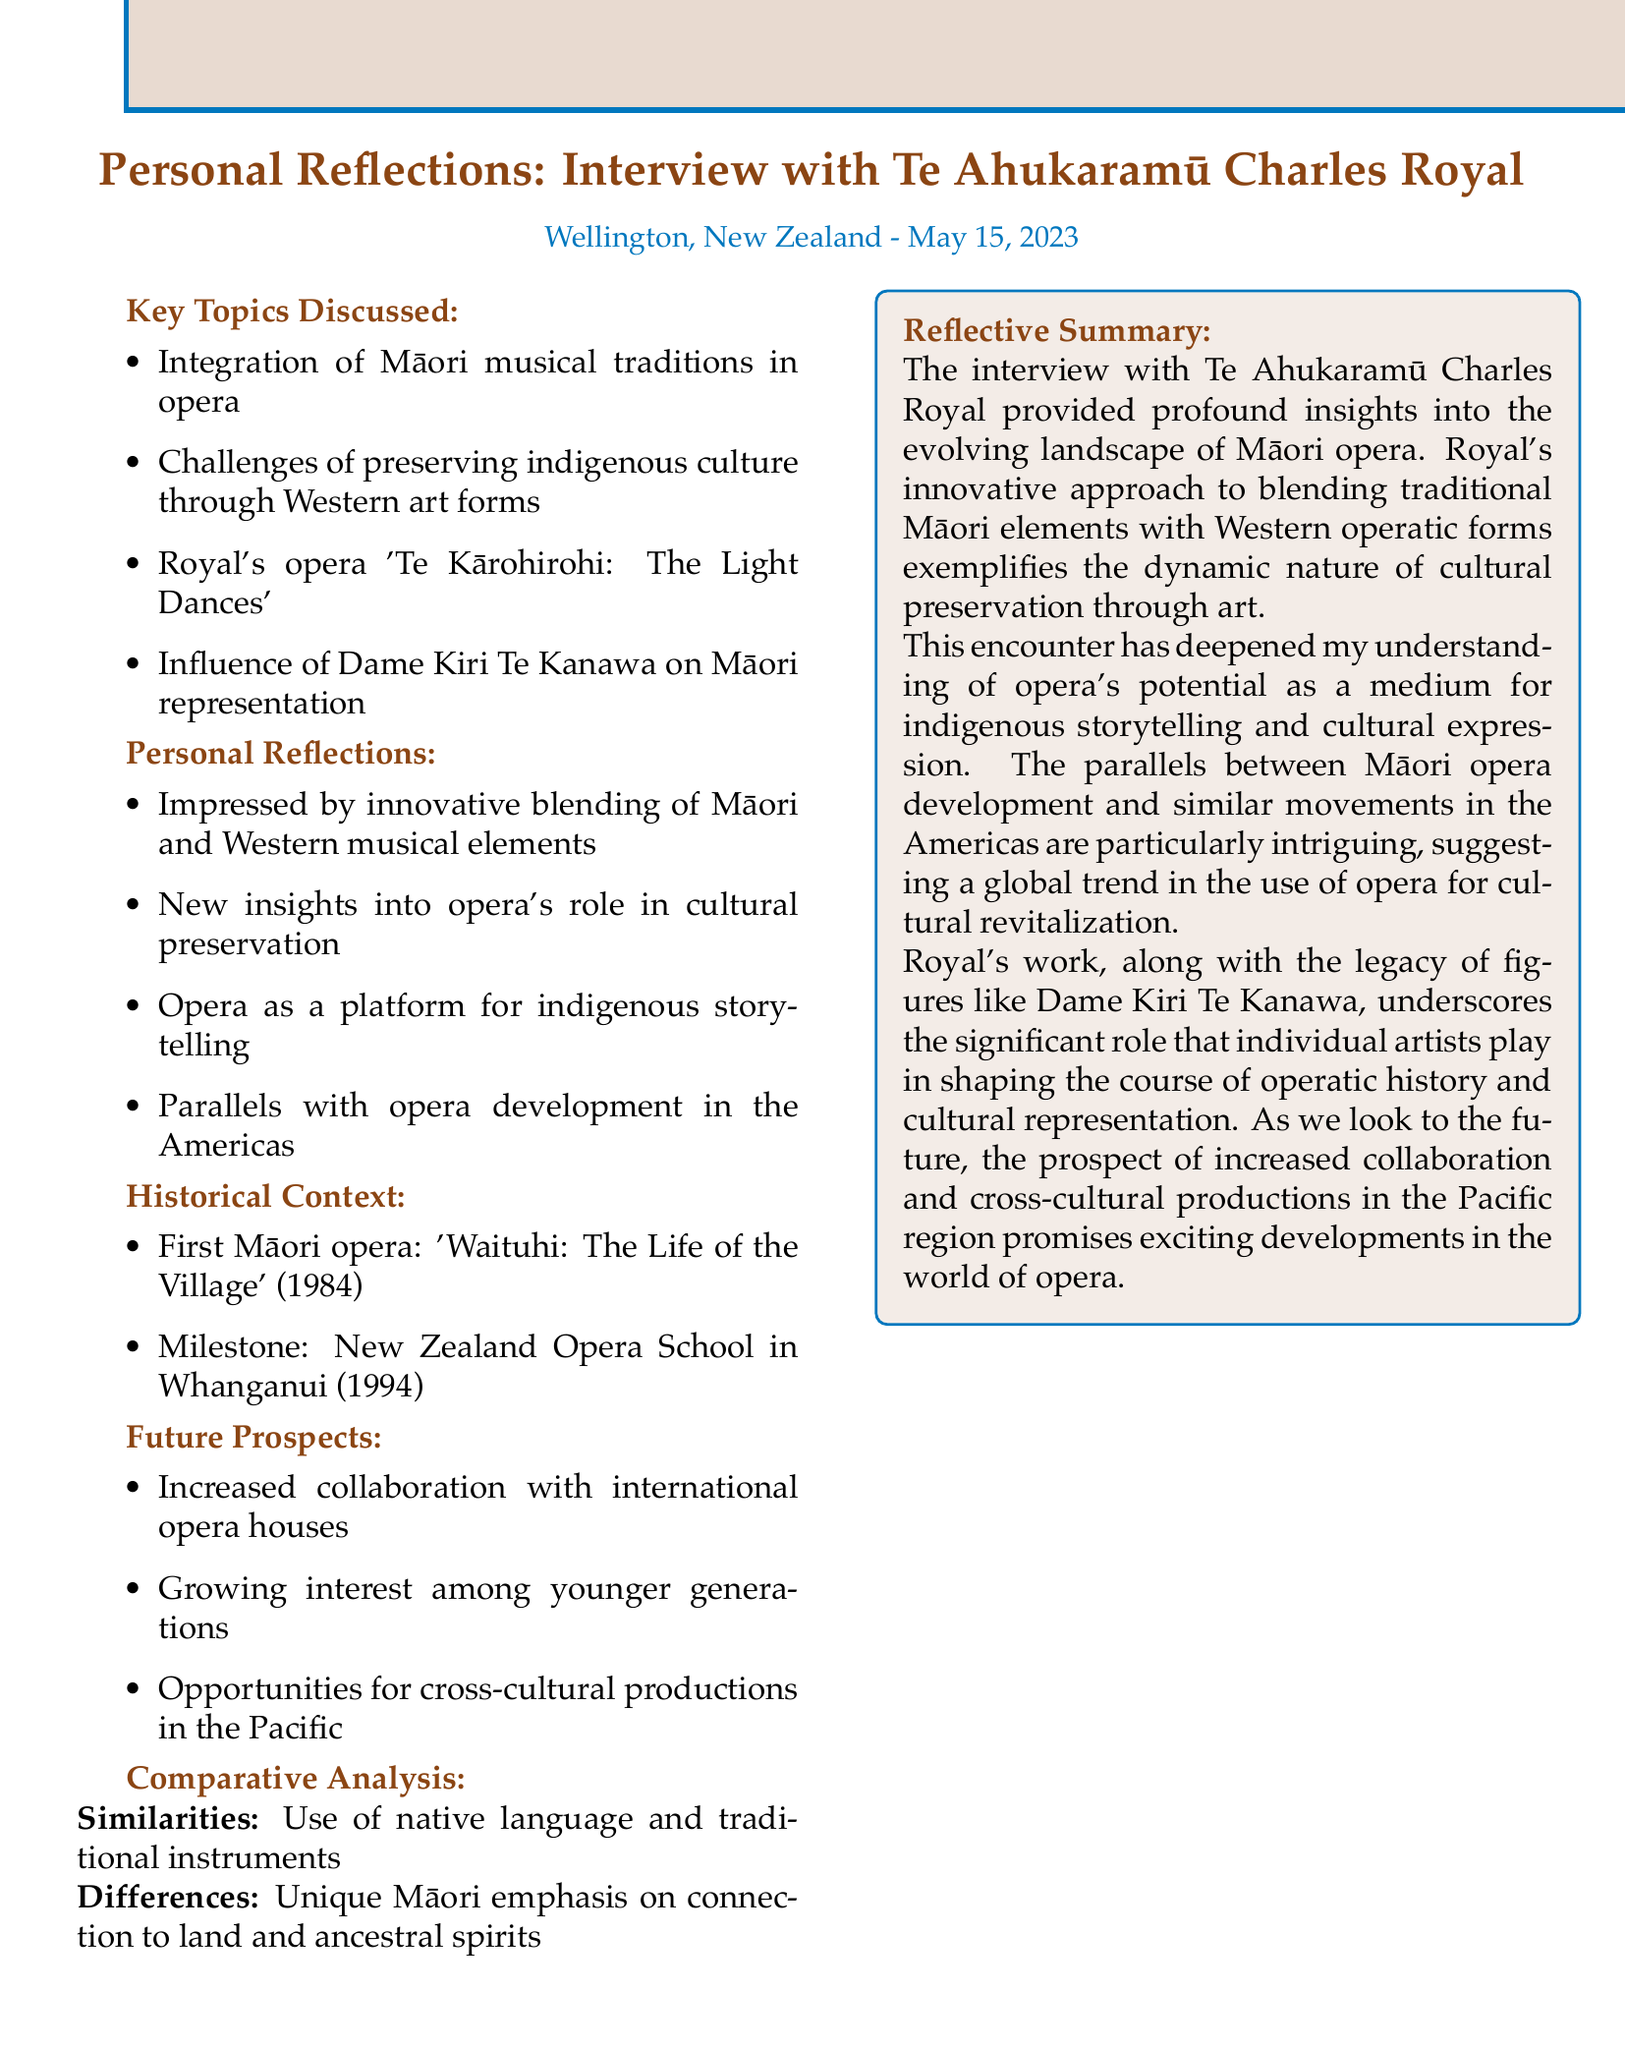What is the name of the composer interviewed? The document states that the composer is Te Ahukaramū Charles Royal.
Answer: Te Ahukaramū Charles Royal When was the interview conducted? The date of the interview is mentioned in the document as May 15, 2023.
Answer: May 15, 2023 What is the title of Royal's groundbreaking opera? The title of Royal's opera is provided in the document as Te Kārohirohi: The Light Dances.
Answer: Te Kārohirohi: The Light Dances What significant milestone occurred in 1994? The document lists the establishment of the New Zealand Opera School in Whanganui as a significant milestone in 1994.
Answer: Establishment of the New Zealand Opera School in Whanganui What aspect of storytelling is uniquely emphasized in Māori opera? The document highlights the unique Māori emphasis on connection to land and ancestral spirits in storytelling.
Answer: Connection to land and ancestral spirits What future opportunity is mentioned regarding Māori composers? The document notes the potential for increased collaboration between Māori composers and international opera houses.
Answer: Increased collaboration with international opera houses Which prominent singer's influence is discussed in the interview? The document indicates that the influence of Dame Kiri Te Kanawa on Māori representation in opera is discussed.
Answer: Dame Kiri Te Kanawa What is a key similarity between Māori opera and other contemporary opera forms? The document mentions the use of native language and traditional instruments as a key similarity.
Answer: Use of native language and traditional instruments 